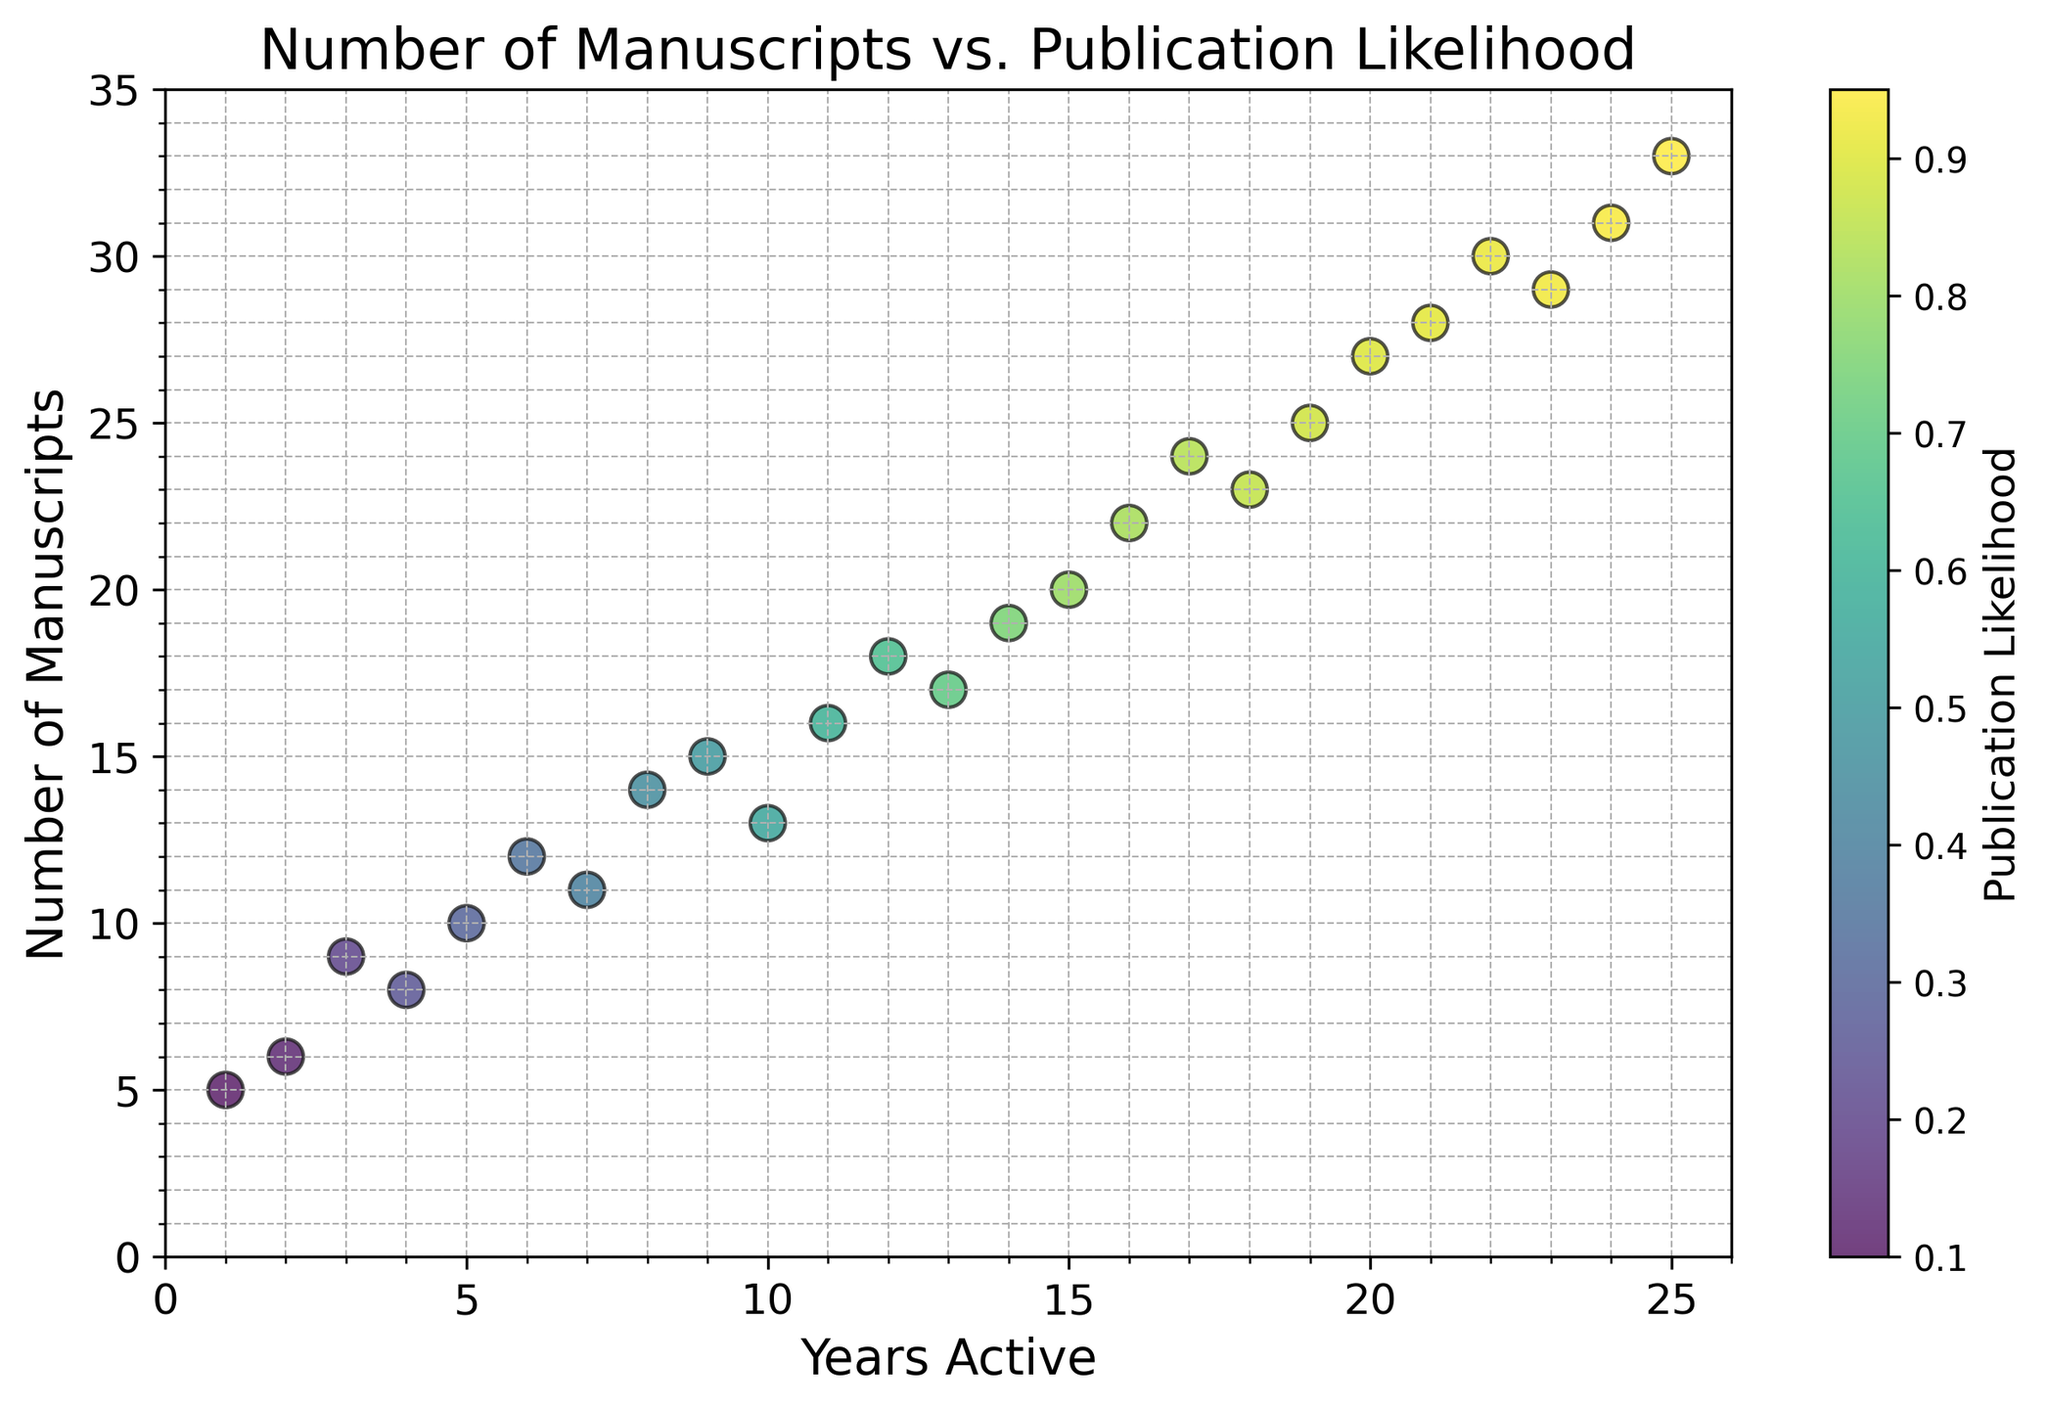How does the number of manuscripts generally change over the years? The number of manuscripts generally increases over the years, as shown by the upward trend of the scatter points from lower left to upper right. This indicates a positive correlation between years active and the number of manuscripts produced.
Answer: Increases Which year had the highest publication likelihood and how many manuscripts were there in that year? The year with the highest publication likelihood is identified by the color gradient, where the darkest color represents the highest likelihood. Observing the scatter points, the darkest point is at year 25. For this year, the number of manuscripts is 33.
Answer: Year 25, 33 manuscripts Is there any year where the number of manuscripts increased but the publication likelihood did not increase? By examining the scatter points, we can determine that between years 16 and 17, while the number of manuscripts increased from 22 to 24, the publication likelihood remained very close, changing subtly from 0.82 to 0.84.
Answer: Yes, between years 16 and 17 Compare the number of manuscripts produced in Year 10 and Year 20. Which year had more manuscripts and by how many? Referencing the scatter points, Year 10 has 13 manuscripts, and Year 20 has 27 manuscripts. To find the difference: 27 - 13 = 14.
Answer: Year 20, by 14 manuscripts What is the general relationship between publication likelihood and the number of manuscripts? The color gradient of the scatter points, which represents publication likelihood, shows that as the number of manuscripts increases, the publication likelihood also increases. This indicates a positive relationship between the two variables.
Answer: Positive relationship What is the average publication likelihood between the first five years? Checking the publication likelihood values for the first five years: 0.1, 0.12, 0.2, 0.25, 0.3. The average is (0.1 + 0.12 + 0.2 + 0.25 + 0.3) / 5 = 0.194.
Answer: 0.194 During which year did the number of manuscripts and publication likelihood both first reach double digits? Analyzing the plot, we find that Year 12 is the first year where the number of manuscripts is 18 (double digits) and the publication likelihood is 0.65 (double digits in percentage terms).
Answer: Year 12 How does the publication likelihood in the first 10 years compare to the last 10 years? Examine the trends from the scatter points for the first 10 and last 10 years. The first 10 years show a gradual increase in publication likelihood, whereas the last 10 years show a consistently higher and steadier climb. This supports that publication likelihood is higher and increases more rapidly in the last 10 years.
Answer: Higher in the last 10 years 